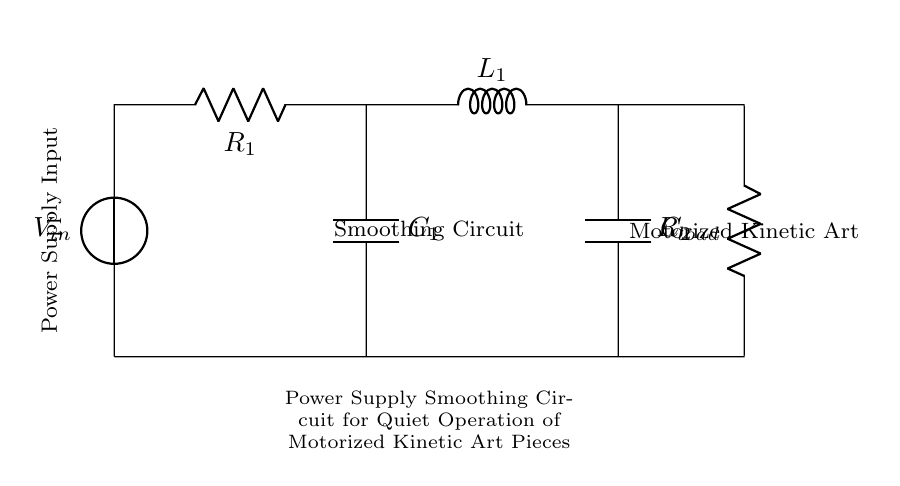What is the voltage source in this circuit? The voltage source is labeled as V_in at the top left corner of the diagram, indicating where the power supply connects into the circuit.
Answer: V_in What is the load resistance in this circuit? The load resistance is indicated as R_load at the bottom right, which represents the resistance experienced by the current flowing to the motorized art piece.
Answer: R_load Which components are used for smoothing? The components used for smoothing in this circuit are C_1 and C_2, which are capacitors placed in parallel to help filter out voltage fluctuations.
Answer: C_1, C_2 How many inductors are present in the circuit? There is one inductor labeled as L_1, which helps to smooth the current and minimize fluctuations during operation.
Answer: 1 What is the primary purpose of this circuit? The primary purpose of this circuit is to ensure quiet operation of motorized kinetic art pieces by smoothing the power supply, reducing unwanted noise from the motors.
Answer: Power Supply Smoothing Explain the effect of adding R_1 on circuit operation. Adding R_1 increases the overall resistance of the circuit, which can help limit the maximum current flowing through and assists in the operation of the smoothing components, ensuring stable voltage.
Answer: Increases resistance 